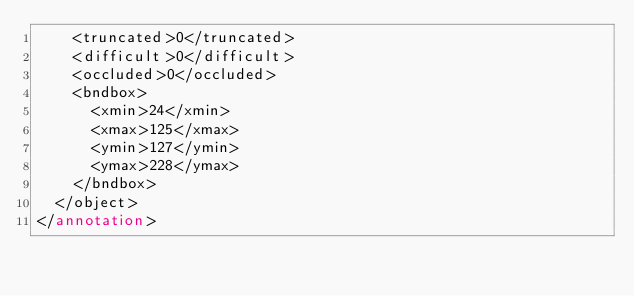Convert code to text. <code><loc_0><loc_0><loc_500><loc_500><_XML_>		<truncated>0</truncated>
		<difficult>0</difficult>
		<occluded>0</occluded>
		<bndbox>
			<xmin>24</xmin>
			<xmax>125</xmax>
			<ymin>127</ymin>
			<ymax>228</ymax>
		</bndbox>
	</object>
</annotation>
</code> 